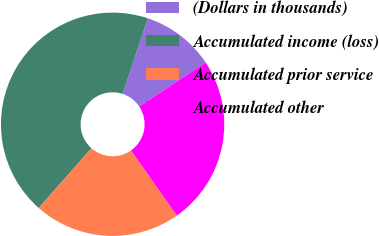Convert chart to OTSL. <chart><loc_0><loc_0><loc_500><loc_500><pie_chart><fcel>(Dollars in thousands)<fcel>Accumulated income (loss)<fcel>Accumulated prior service<fcel>Accumulated other<nl><fcel>10.57%<fcel>43.59%<fcel>21.27%<fcel>24.57%<nl></chart> 